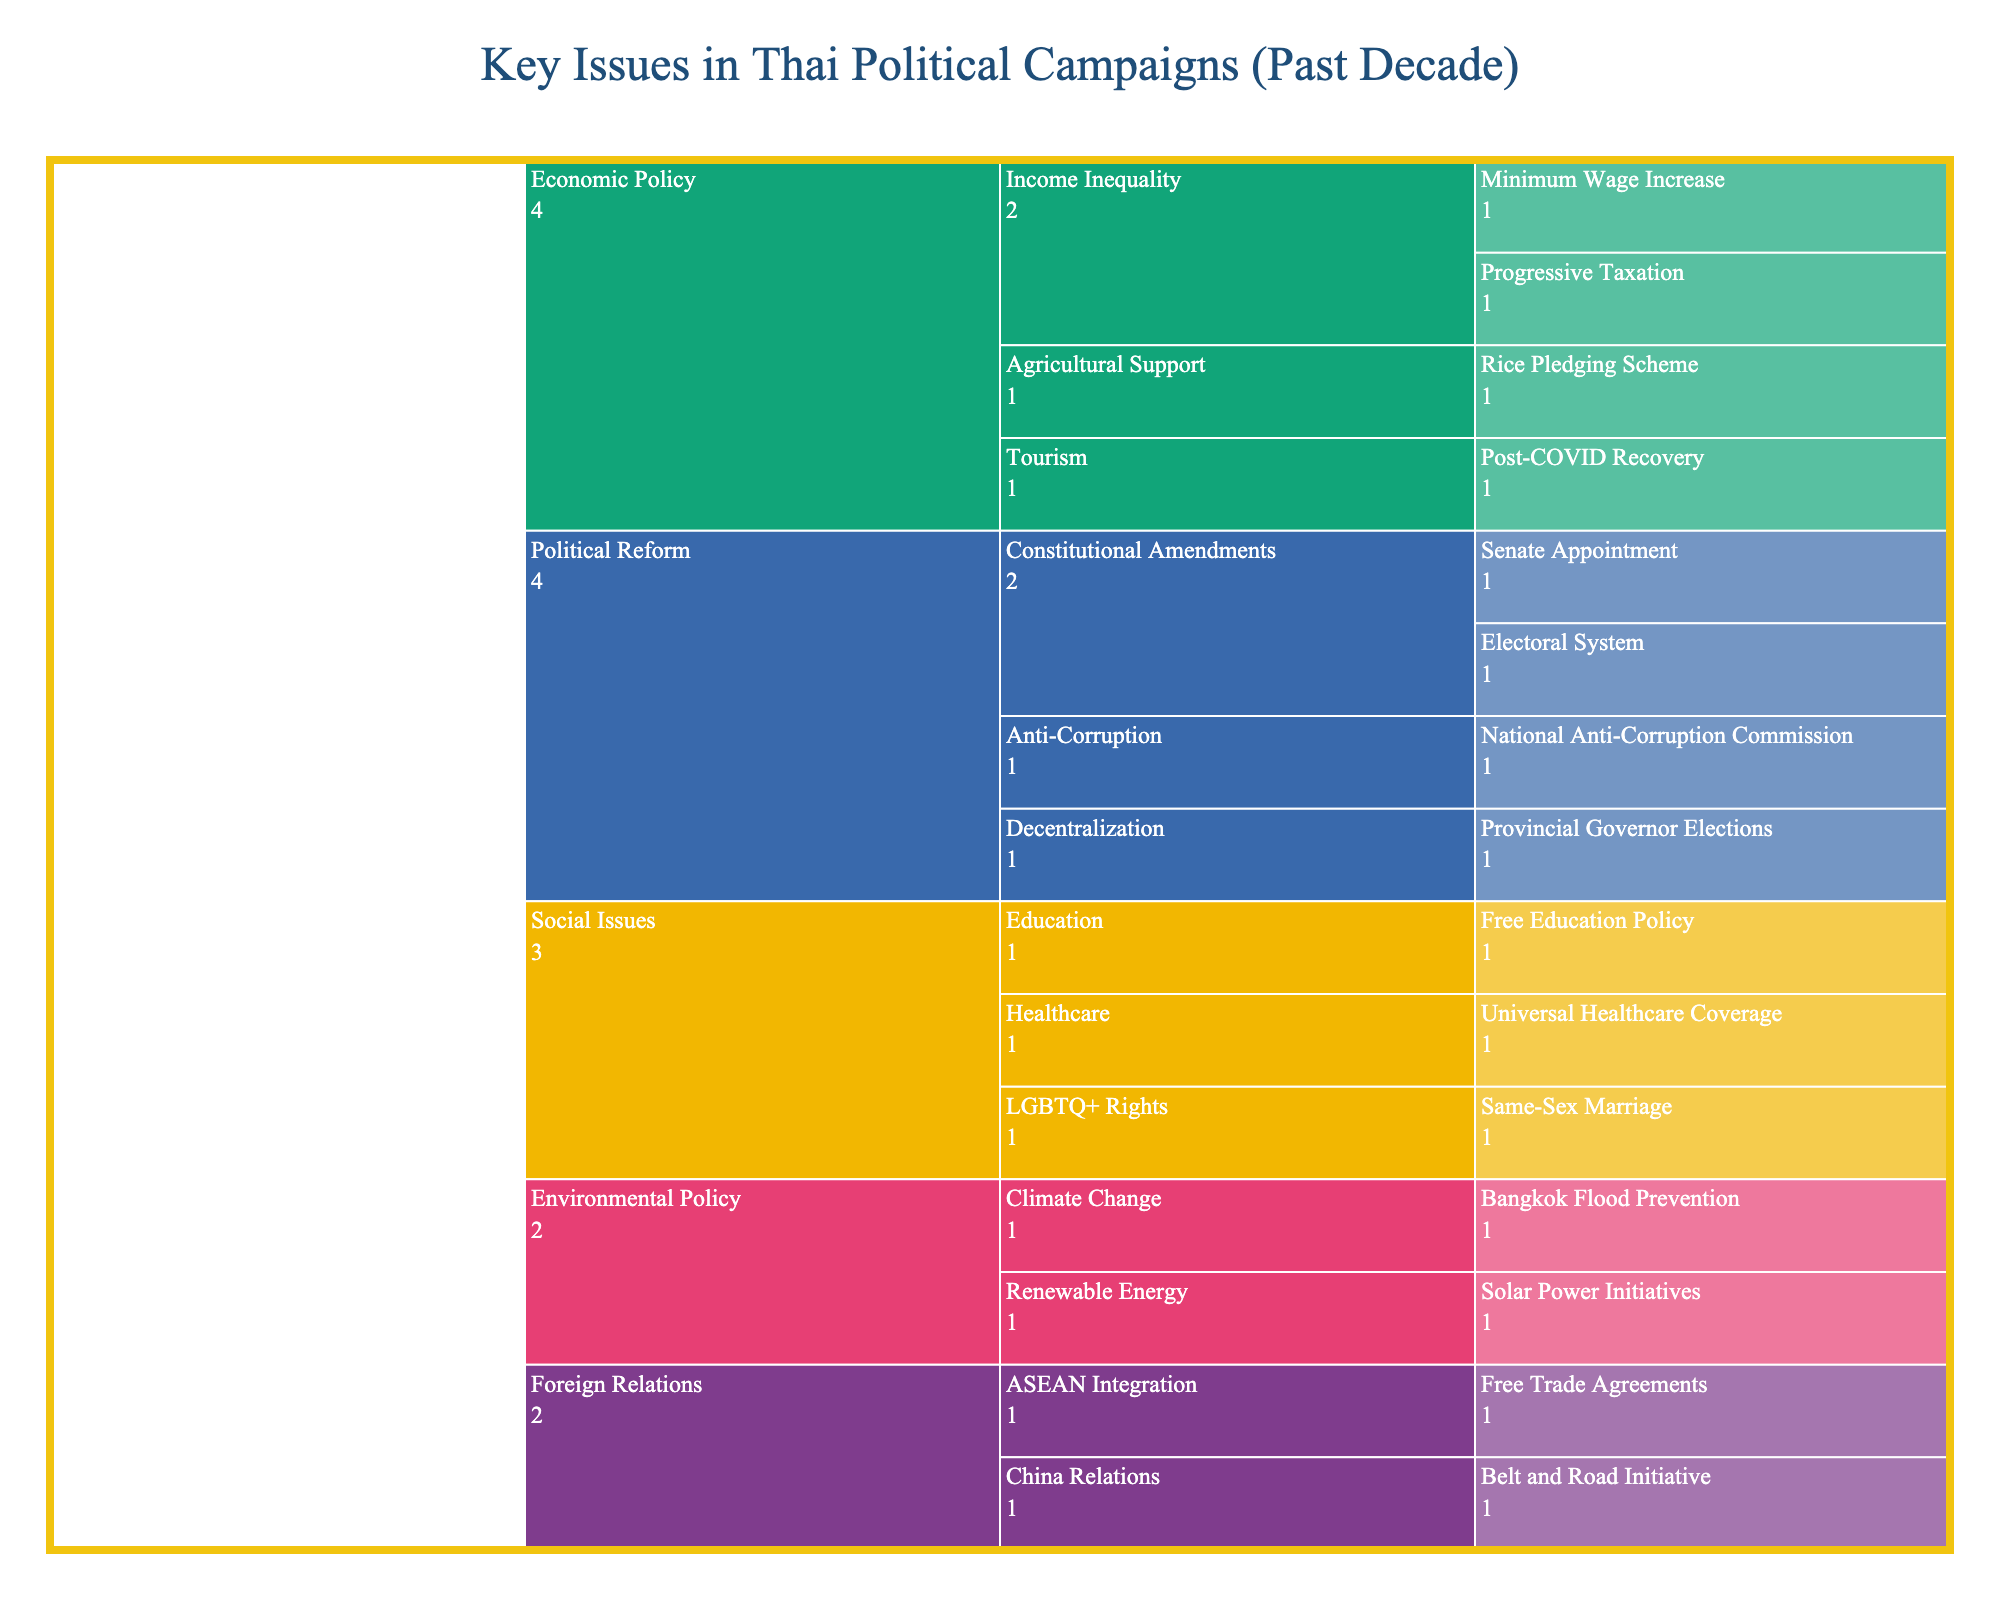What is the title of the Icicle Chart? The title of the chart is usually positioned at the top of the figure, prominent and readable to provide an immediate understanding of what the chart represents. The title of this specific chart is "Key Issues in Thai Political Campaigns (Past Decade)."
Answer: Key Issues in Thai Political Campaigns (Past Decade) How many primary categories are represented in the chart? To find this, you first identify the primary segments or root nodes of the icicle chart. Each unique segment at the first level represents a primary category. In this chart, the primary categories are "Political Reform," "Economic Policy," "Social Issues," "Environmental Policy," and "Foreign Relations." There are 5 primary categories in total.
Answer: 5 Which subcategory under "Economic Policy" includes issues related to agriculture? First, locate the "Economic Policy" section, and then identify the subcategories within it. The subcategory related to agriculture is "Agricultural Support." The specific issue under this subcategory is the "Rice Pledging Scheme."
Answer: Agricultural Support Does the chart highlight more issues under "Political Reform" or "Environmental Policy"? To answer this, you need to compare the number of unique issues listed under each category. "Political Reform" includes issues like "Senate Appointment," "Electoral System," "Provincial Governor Elections," and "National Anti-Corruption Commission," totaling 4 issues. "Environmental Policy" includes "Bangkok Flood Prevention" and "Solar Power Initiatives," totaling 2 issues. Therefore, "Political Reform" has more issues highlighted.
Answer: Political Reform What's the specific issue listed under "Healthcare" in the chart? Locate the "Social Issues" category, and then identify the subcategory "Healthcare." The issue listed under this subcategory is "Universal Healthcare Coverage."
Answer: Universal Healthcare Coverage How does the number of issues related to "Income Inequality" compare to those related to "LGBTQ+ Rights"? First, locate and count the issues related to "Income Inequality" under the "Economic Policy" category, which includes "Minimum Wage Increase" and "Progressive Taxation," totaling 2 issues. Then, locate and count the issues under "LGBTQ+ Rights" in the "Social Issues" category, which lists only one issue, "Same-Sex Marriage." Thus, there are more issues related to "Income Inequality" than to "LGBTQ+ Rights."
Answer: Income Inequality has more Under which primary category does the issue "Free Trade Agreements" fall? Locate the issue "Free Trade Agreements" within the branches of the icicle chart. It falls under the primary category "Foreign Relations" and the subcategory "ASEAN Integration."
Answer: Foreign Relations Identify the number of subcategories within "Political Reform." Find the "Political Reform" segment and then count all subcategories within this category. The subcategories are "Constitutional Amendments," "Decentralization," and "Anti-Corruption," which totals to 3 subcategories.
Answer: 3 What is the common theme among the issues listed in the "Environmental Policy" category? The common theme among all the issues under the "Environmental Policy" category revolves around combating and managing environmental changes. The specific issues listed are "Bangkok Flood Prevention" and "Solar Power Initiatives," both aiming to address climate change and promote sustainability.
Answer: Climate and sustainability Which category includes the issue related to "Post-COVID Recovery"? Locate the issue "Post-COVID Recovery" in the chart. It falls under the category "Economic Policy" and the subcategory "Tourism."
Answer: Economic Policy 